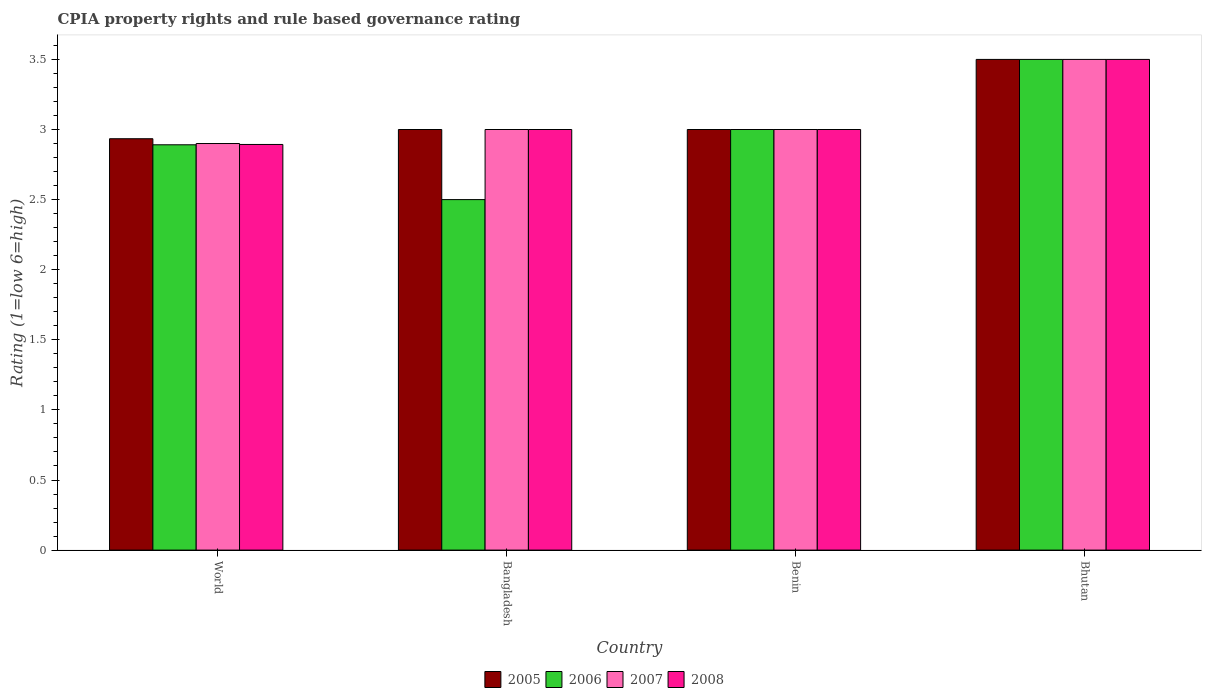How many bars are there on the 2nd tick from the left?
Provide a short and direct response. 4. What is the label of the 3rd group of bars from the left?
Make the answer very short. Benin. What is the CPIA rating in 2006 in World?
Offer a very short reply. 2.89. Across all countries, what is the minimum CPIA rating in 2006?
Provide a short and direct response. 2.5. In which country was the CPIA rating in 2007 maximum?
Offer a very short reply. Bhutan. In which country was the CPIA rating in 2006 minimum?
Provide a short and direct response. Bangladesh. What is the total CPIA rating in 2006 in the graph?
Make the answer very short. 11.89. What is the difference between the CPIA rating in 2005 in Benin and that in Bhutan?
Keep it short and to the point. -0.5. What is the difference between the CPIA rating in 2005 in Bangladesh and the CPIA rating in 2008 in World?
Ensure brevity in your answer.  0.11. What is the average CPIA rating in 2006 per country?
Provide a succinct answer. 2.97. What is the ratio of the CPIA rating in 2008 in Benin to that in World?
Provide a short and direct response. 1.04. Is the CPIA rating in 2005 in Bangladesh less than that in Benin?
Make the answer very short. No. What is the difference between the highest and the second highest CPIA rating in 2006?
Your answer should be compact. 0.11. What is the difference between the highest and the lowest CPIA rating in 2005?
Your response must be concise. 0.57. Is the sum of the CPIA rating in 2008 in Benin and Bhutan greater than the maximum CPIA rating in 2006 across all countries?
Your answer should be very brief. Yes. Is it the case that in every country, the sum of the CPIA rating in 2007 and CPIA rating in 2005 is greater than the sum of CPIA rating in 2008 and CPIA rating in 2006?
Your answer should be compact. No. What does the 2nd bar from the left in Benin represents?
Provide a succinct answer. 2006. What does the 3rd bar from the right in Bangladesh represents?
Ensure brevity in your answer.  2006. Is it the case that in every country, the sum of the CPIA rating in 2007 and CPIA rating in 2008 is greater than the CPIA rating in 2006?
Make the answer very short. Yes. Does the graph contain grids?
Keep it short and to the point. No. What is the title of the graph?
Make the answer very short. CPIA property rights and rule based governance rating. What is the Rating (1=low 6=high) of 2005 in World?
Your response must be concise. 2.93. What is the Rating (1=low 6=high) in 2006 in World?
Provide a succinct answer. 2.89. What is the Rating (1=low 6=high) of 2007 in World?
Your answer should be compact. 2.9. What is the Rating (1=low 6=high) of 2008 in World?
Offer a terse response. 2.89. What is the Rating (1=low 6=high) in 2005 in Bangladesh?
Keep it short and to the point. 3. What is the Rating (1=low 6=high) of 2006 in Benin?
Offer a very short reply. 3. What is the Rating (1=low 6=high) in 2007 in Benin?
Your response must be concise. 3. What is the Rating (1=low 6=high) in 2008 in Bhutan?
Keep it short and to the point. 3.5. Across all countries, what is the maximum Rating (1=low 6=high) in 2005?
Make the answer very short. 3.5. Across all countries, what is the maximum Rating (1=low 6=high) in 2008?
Keep it short and to the point. 3.5. Across all countries, what is the minimum Rating (1=low 6=high) of 2005?
Keep it short and to the point. 2.93. Across all countries, what is the minimum Rating (1=low 6=high) in 2007?
Offer a terse response. 2.9. Across all countries, what is the minimum Rating (1=low 6=high) in 2008?
Ensure brevity in your answer.  2.89. What is the total Rating (1=low 6=high) of 2005 in the graph?
Provide a succinct answer. 12.43. What is the total Rating (1=low 6=high) in 2006 in the graph?
Provide a short and direct response. 11.89. What is the total Rating (1=low 6=high) in 2007 in the graph?
Give a very brief answer. 12.4. What is the total Rating (1=low 6=high) of 2008 in the graph?
Your answer should be compact. 12.39. What is the difference between the Rating (1=low 6=high) of 2005 in World and that in Bangladesh?
Provide a short and direct response. -0.07. What is the difference between the Rating (1=low 6=high) in 2006 in World and that in Bangladesh?
Give a very brief answer. 0.39. What is the difference between the Rating (1=low 6=high) of 2007 in World and that in Bangladesh?
Give a very brief answer. -0.1. What is the difference between the Rating (1=low 6=high) of 2008 in World and that in Bangladesh?
Your answer should be very brief. -0.11. What is the difference between the Rating (1=low 6=high) of 2005 in World and that in Benin?
Ensure brevity in your answer.  -0.07. What is the difference between the Rating (1=low 6=high) of 2006 in World and that in Benin?
Make the answer very short. -0.11. What is the difference between the Rating (1=low 6=high) of 2007 in World and that in Benin?
Provide a short and direct response. -0.1. What is the difference between the Rating (1=low 6=high) in 2008 in World and that in Benin?
Ensure brevity in your answer.  -0.11. What is the difference between the Rating (1=low 6=high) in 2005 in World and that in Bhutan?
Offer a terse response. -0.57. What is the difference between the Rating (1=low 6=high) in 2006 in World and that in Bhutan?
Make the answer very short. -0.61. What is the difference between the Rating (1=low 6=high) in 2008 in World and that in Bhutan?
Provide a succinct answer. -0.61. What is the difference between the Rating (1=low 6=high) of 2007 in Bangladesh and that in Benin?
Offer a terse response. 0. What is the difference between the Rating (1=low 6=high) of 2008 in Bangladesh and that in Benin?
Offer a very short reply. 0. What is the difference between the Rating (1=low 6=high) in 2005 in Bangladesh and that in Bhutan?
Your answer should be compact. -0.5. What is the difference between the Rating (1=low 6=high) in 2006 in Bangladesh and that in Bhutan?
Give a very brief answer. -1. What is the difference between the Rating (1=low 6=high) of 2007 in Bangladesh and that in Bhutan?
Your answer should be very brief. -0.5. What is the difference between the Rating (1=low 6=high) in 2005 in Benin and that in Bhutan?
Keep it short and to the point. -0.5. What is the difference between the Rating (1=low 6=high) in 2006 in Benin and that in Bhutan?
Offer a very short reply. -0.5. What is the difference between the Rating (1=low 6=high) of 2005 in World and the Rating (1=low 6=high) of 2006 in Bangladesh?
Ensure brevity in your answer.  0.43. What is the difference between the Rating (1=low 6=high) of 2005 in World and the Rating (1=low 6=high) of 2007 in Bangladesh?
Keep it short and to the point. -0.07. What is the difference between the Rating (1=low 6=high) of 2005 in World and the Rating (1=low 6=high) of 2008 in Bangladesh?
Your answer should be very brief. -0.07. What is the difference between the Rating (1=low 6=high) in 2006 in World and the Rating (1=low 6=high) in 2007 in Bangladesh?
Provide a succinct answer. -0.11. What is the difference between the Rating (1=low 6=high) in 2006 in World and the Rating (1=low 6=high) in 2008 in Bangladesh?
Ensure brevity in your answer.  -0.11. What is the difference between the Rating (1=low 6=high) of 2005 in World and the Rating (1=low 6=high) of 2006 in Benin?
Offer a terse response. -0.07. What is the difference between the Rating (1=low 6=high) in 2005 in World and the Rating (1=low 6=high) in 2007 in Benin?
Provide a short and direct response. -0.07. What is the difference between the Rating (1=low 6=high) of 2005 in World and the Rating (1=low 6=high) of 2008 in Benin?
Your answer should be very brief. -0.07. What is the difference between the Rating (1=low 6=high) in 2006 in World and the Rating (1=low 6=high) in 2007 in Benin?
Your response must be concise. -0.11. What is the difference between the Rating (1=low 6=high) of 2006 in World and the Rating (1=low 6=high) of 2008 in Benin?
Ensure brevity in your answer.  -0.11. What is the difference between the Rating (1=low 6=high) in 2007 in World and the Rating (1=low 6=high) in 2008 in Benin?
Offer a terse response. -0.1. What is the difference between the Rating (1=low 6=high) in 2005 in World and the Rating (1=low 6=high) in 2006 in Bhutan?
Make the answer very short. -0.57. What is the difference between the Rating (1=low 6=high) in 2005 in World and the Rating (1=low 6=high) in 2007 in Bhutan?
Offer a terse response. -0.57. What is the difference between the Rating (1=low 6=high) in 2005 in World and the Rating (1=low 6=high) in 2008 in Bhutan?
Make the answer very short. -0.57. What is the difference between the Rating (1=low 6=high) of 2006 in World and the Rating (1=low 6=high) of 2007 in Bhutan?
Keep it short and to the point. -0.61. What is the difference between the Rating (1=low 6=high) of 2006 in World and the Rating (1=low 6=high) of 2008 in Bhutan?
Offer a very short reply. -0.61. What is the difference between the Rating (1=low 6=high) in 2005 in Bangladesh and the Rating (1=low 6=high) in 2006 in Benin?
Make the answer very short. 0. What is the difference between the Rating (1=low 6=high) in 2005 in Bangladesh and the Rating (1=low 6=high) in 2007 in Benin?
Your answer should be very brief. 0. What is the difference between the Rating (1=low 6=high) in 2006 in Bangladesh and the Rating (1=low 6=high) in 2007 in Benin?
Keep it short and to the point. -0.5. What is the difference between the Rating (1=low 6=high) of 2006 in Bangladesh and the Rating (1=low 6=high) of 2008 in Benin?
Your response must be concise. -0.5. What is the difference between the Rating (1=low 6=high) in 2005 in Bangladesh and the Rating (1=low 6=high) in 2006 in Bhutan?
Keep it short and to the point. -0.5. What is the difference between the Rating (1=low 6=high) of 2006 in Bangladesh and the Rating (1=low 6=high) of 2007 in Bhutan?
Provide a succinct answer. -1. What is the difference between the Rating (1=low 6=high) in 2005 in Benin and the Rating (1=low 6=high) in 2007 in Bhutan?
Keep it short and to the point. -0.5. What is the average Rating (1=low 6=high) in 2005 per country?
Provide a short and direct response. 3.11. What is the average Rating (1=low 6=high) in 2006 per country?
Your answer should be very brief. 2.97. What is the average Rating (1=low 6=high) in 2008 per country?
Offer a very short reply. 3.1. What is the difference between the Rating (1=low 6=high) in 2005 and Rating (1=low 6=high) in 2006 in World?
Provide a succinct answer. 0.04. What is the difference between the Rating (1=low 6=high) of 2005 and Rating (1=low 6=high) of 2007 in World?
Your response must be concise. 0.03. What is the difference between the Rating (1=low 6=high) in 2005 and Rating (1=low 6=high) in 2008 in World?
Provide a short and direct response. 0.04. What is the difference between the Rating (1=low 6=high) of 2006 and Rating (1=low 6=high) of 2007 in World?
Offer a terse response. -0.01. What is the difference between the Rating (1=low 6=high) of 2006 and Rating (1=low 6=high) of 2008 in World?
Offer a terse response. -0. What is the difference between the Rating (1=low 6=high) in 2007 and Rating (1=low 6=high) in 2008 in World?
Your answer should be compact. 0.01. What is the difference between the Rating (1=low 6=high) in 2005 and Rating (1=low 6=high) in 2006 in Bangladesh?
Give a very brief answer. 0.5. What is the difference between the Rating (1=low 6=high) of 2005 and Rating (1=low 6=high) of 2007 in Bangladesh?
Your response must be concise. 0. What is the difference between the Rating (1=low 6=high) in 2006 and Rating (1=low 6=high) in 2007 in Bangladesh?
Provide a succinct answer. -0.5. What is the difference between the Rating (1=low 6=high) of 2005 and Rating (1=low 6=high) of 2006 in Benin?
Ensure brevity in your answer.  0. What is the difference between the Rating (1=low 6=high) in 2005 and Rating (1=low 6=high) in 2007 in Benin?
Your answer should be compact. 0. What is the difference between the Rating (1=low 6=high) of 2005 and Rating (1=low 6=high) of 2008 in Benin?
Offer a very short reply. 0. What is the difference between the Rating (1=low 6=high) in 2006 and Rating (1=low 6=high) in 2007 in Benin?
Keep it short and to the point. 0. What is the difference between the Rating (1=low 6=high) of 2005 and Rating (1=low 6=high) of 2006 in Bhutan?
Your answer should be compact. 0. What is the difference between the Rating (1=low 6=high) of 2005 and Rating (1=low 6=high) of 2007 in Bhutan?
Provide a short and direct response. 0. What is the difference between the Rating (1=low 6=high) of 2005 and Rating (1=low 6=high) of 2008 in Bhutan?
Make the answer very short. 0. What is the difference between the Rating (1=low 6=high) in 2006 and Rating (1=low 6=high) in 2008 in Bhutan?
Your answer should be compact. 0. What is the difference between the Rating (1=low 6=high) of 2007 and Rating (1=low 6=high) of 2008 in Bhutan?
Ensure brevity in your answer.  0. What is the ratio of the Rating (1=low 6=high) of 2005 in World to that in Bangladesh?
Your answer should be very brief. 0.98. What is the ratio of the Rating (1=low 6=high) in 2006 in World to that in Bangladesh?
Offer a terse response. 1.16. What is the ratio of the Rating (1=low 6=high) of 2007 in World to that in Bangladesh?
Your answer should be compact. 0.97. What is the ratio of the Rating (1=low 6=high) in 2008 in World to that in Bangladesh?
Your answer should be compact. 0.96. What is the ratio of the Rating (1=low 6=high) in 2005 in World to that in Benin?
Offer a very short reply. 0.98. What is the ratio of the Rating (1=low 6=high) of 2006 in World to that in Benin?
Ensure brevity in your answer.  0.96. What is the ratio of the Rating (1=low 6=high) of 2007 in World to that in Benin?
Ensure brevity in your answer.  0.97. What is the ratio of the Rating (1=low 6=high) of 2008 in World to that in Benin?
Provide a short and direct response. 0.96. What is the ratio of the Rating (1=low 6=high) in 2005 in World to that in Bhutan?
Your answer should be very brief. 0.84. What is the ratio of the Rating (1=low 6=high) of 2006 in World to that in Bhutan?
Your answer should be very brief. 0.83. What is the ratio of the Rating (1=low 6=high) of 2007 in World to that in Bhutan?
Your response must be concise. 0.83. What is the ratio of the Rating (1=low 6=high) of 2008 in World to that in Bhutan?
Provide a succinct answer. 0.83. What is the ratio of the Rating (1=low 6=high) of 2006 in Bangladesh to that in Benin?
Give a very brief answer. 0.83. What is the ratio of the Rating (1=low 6=high) of 2007 in Bangladesh to that in Benin?
Your answer should be very brief. 1. What is the ratio of the Rating (1=low 6=high) in 2008 in Bangladesh to that in Benin?
Your answer should be compact. 1. What is the ratio of the Rating (1=low 6=high) in 2006 in Bangladesh to that in Bhutan?
Your answer should be very brief. 0.71. What is the ratio of the Rating (1=low 6=high) of 2008 in Bangladesh to that in Bhutan?
Offer a terse response. 0.86. What is the ratio of the Rating (1=low 6=high) in 2006 in Benin to that in Bhutan?
Your answer should be very brief. 0.86. What is the difference between the highest and the second highest Rating (1=low 6=high) in 2005?
Make the answer very short. 0.5. What is the difference between the highest and the second highest Rating (1=low 6=high) of 2006?
Offer a terse response. 0.5. What is the difference between the highest and the second highest Rating (1=low 6=high) in 2007?
Ensure brevity in your answer.  0.5. What is the difference between the highest and the lowest Rating (1=low 6=high) of 2005?
Your answer should be compact. 0.57. What is the difference between the highest and the lowest Rating (1=low 6=high) in 2007?
Provide a short and direct response. 0.6. What is the difference between the highest and the lowest Rating (1=low 6=high) of 2008?
Offer a terse response. 0.61. 